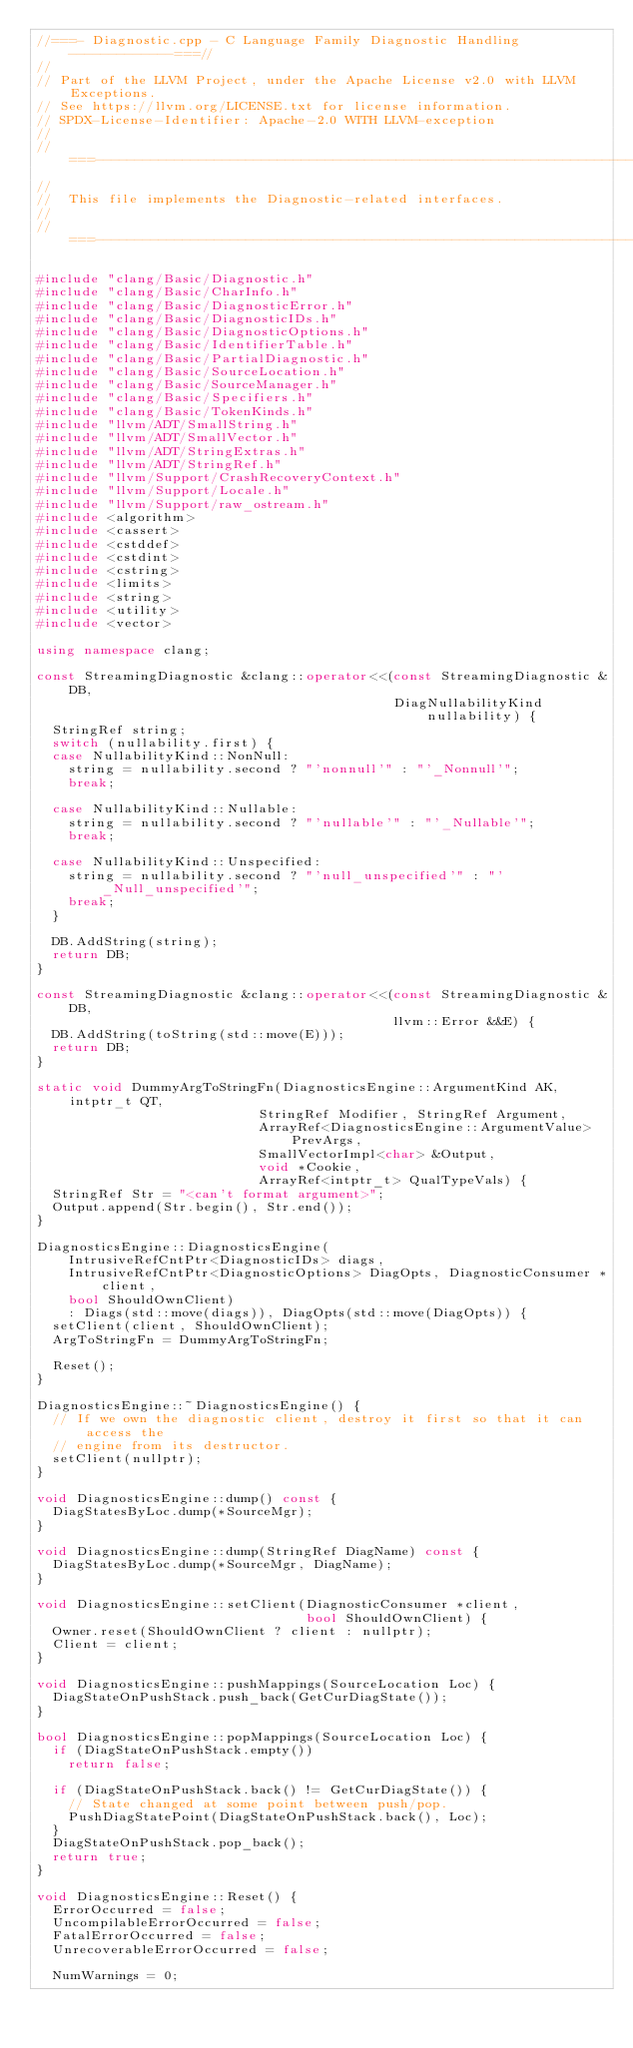Convert code to text. <code><loc_0><loc_0><loc_500><loc_500><_C++_>//===- Diagnostic.cpp - C Language Family Diagnostic Handling -------------===//
//
// Part of the LLVM Project, under the Apache License v2.0 with LLVM Exceptions.
// See https://llvm.org/LICENSE.txt for license information.
// SPDX-License-Identifier: Apache-2.0 WITH LLVM-exception
//
//===----------------------------------------------------------------------===//
//
//  This file implements the Diagnostic-related interfaces.
//
//===----------------------------------------------------------------------===//

#include "clang/Basic/Diagnostic.h"
#include "clang/Basic/CharInfo.h"
#include "clang/Basic/DiagnosticError.h"
#include "clang/Basic/DiagnosticIDs.h"
#include "clang/Basic/DiagnosticOptions.h"
#include "clang/Basic/IdentifierTable.h"
#include "clang/Basic/PartialDiagnostic.h"
#include "clang/Basic/SourceLocation.h"
#include "clang/Basic/SourceManager.h"
#include "clang/Basic/Specifiers.h"
#include "clang/Basic/TokenKinds.h"
#include "llvm/ADT/SmallString.h"
#include "llvm/ADT/SmallVector.h"
#include "llvm/ADT/StringExtras.h"
#include "llvm/ADT/StringRef.h"
#include "llvm/Support/CrashRecoveryContext.h"
#include "llvm/Support/Locale.h"
#include "llvm/Support/raw_ostream.h"
#include <algorithm>
#include <cassert>
#include <cstddef>
#include <cstdint>
#include <cstring>
#include <limits>
#include <string>
#include <utility>
#include <vector>

using namespace clang;

const StreamingDiagnostic &clang::operator<<(const StreamingDiagnostic &DB,
                                             DiagNullabilityKind nullability) {
  StringRef string;
  switch (nullability.first) {
  case NullabilityKind::NonNull:
    string = nullability.second ? "'nonnull'" : "'_Nonnull'";
    break;

  case NullabilityKind::Nullable:
    string = nullability.second ? "'nullable'" : "'_Nullable'";
    break;

  case NullabilityKind::Unspecified:
    string = nullability.second ? "'null_unspecified'" : "'_Null_unspecified'";
    break;
  }

  DB.AddString(string);
  return DB;
}

const StreamingDiagnostic &clang::operator<<(const StreamingDiagnostic &DB,
                                             llvm::Error &&E) {
  DB.AddString(toString(std::move(E)));
  return DB;
}

static void DummyArgToStringFn(DiagnosticsEngine::ArgumentKind AK, intptr_t QT,
                            StringRef Modifier, StringRef Argument,
                            ArrayRef<DiagnosticsEngine::ArgumentValue> PrevArgs,
                            SmallVectorImpl<char> &Output,
                            void *Cookie,
                            ArrayRef<intptr_t> QualTypeVals) {
  StringRef Str = "<can't format argument>";
  Output.append(Str.begin(), Str.end());
}

DiagnosticsEngine::DiagnosticsEngine(
    IntrusiveRefCntPtr<DiagnosticIDs> diags,
    IntrusiveRefCntPtr<DiagnosticOptions> DiagOpts, DiagnosticConsumer *client,
    bool ShouldOwnClient)
    : Diags(std::move(diags)), DiagOpts(std::move(DiagOpts)) {
  setClient(client, ShouldOwnClient);
  ArgToStringFn = DummyArgToStringFn;

  Reset();
}

DiagnosticsEngine::~DiagnosticsEngine() {
  // If we own the diagnostic client, destroy it first so that it can access the
  // engine from its destructor.
  setClient(nullptr);
}

void DiagnosticsEngine::dump() const {
  DiagStatesByLoc.dump(*SourceMgr);
}

void DiagnosticsEngine::dump(StringRef DiagName) const {
  DiagStatesByLoc.dump(*SourceMgr, DiagName);
}

void DiagnosticsEngine::setClient(DiagnosticConsumer *client,
                                  bool ShouldOwnClient) {
  Owner.reset(ShouldOwnClient ? client : nullptr);
  Client = client;
}

void DiagnosticsEngine::pushMappings(SourceLocation Loc) {
  DiagStateOnPushStack.push_back(GetCurDiagState());
}

bool DiagnosticsEngine::popMappings(SourceLocation Loc) {
  if (DiagStateOnPushStack.empty())
    return false;

  if (DiagStateOnPushStack.back() != GetCurDiagState()) {
    // State changed at some point between push/pop.
    PushDiagStatePoint(DiagStateOnPushStack.back(), Loc);
  }
  DiagStateOnPushStack.pop_back();
  return true;
}

void DiagnosticsEngine::Reset() {
  ErrorOccurred = false;
  UncompilableErrorOccurred = false;
  FatalErrorOccurred = false;
  UnrecoverableErrorOccurred = false;

  NumWarnings = 0;</code> 